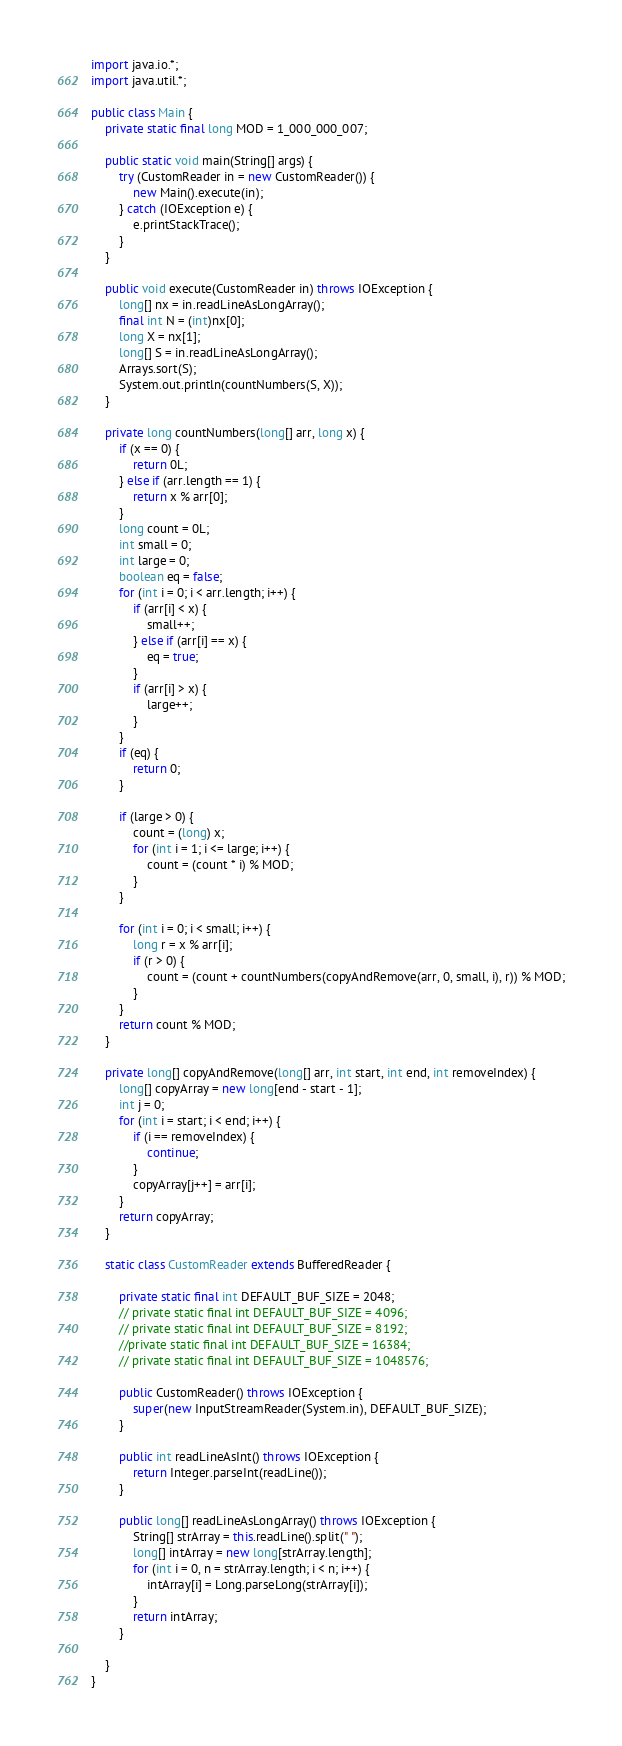<code> <loc_0><loc_0><loc_500><loc_500><_Java_>import java.io.*;
import java.util.*;

public class Main {
    private static final long MOD = 1_000_000_007;

    public static void main(String[] args) {
        try (CustomReader in = new CustomReader()) {
            new Main().execute(in);
        } catch (IOException e) {
            e.printStackTrace();
        }
    }

    public void execute(CustomReader in) throws IOException {
        long[] nx = in.readLineAsLongArray();
        final int N = (int)nx[0];
        long X = nx[1];
        long[] S = in.readLineAsLongArray();
        Arrays.sort(S);
        System.out.println(countNumbers(S, X));
    }

    private long countNumbers(long[] arr, long x) {
        if (x == 0) {
            return 0L;
        } else if (arr.length == 1) {
            return x % arr[0];
        }
        long count = 0L;
        int small = 0;
        int large = 0;
        boolean eq = false;
        for (int i = 0; i < arr.length; i++) {
            if (arr[i] < x) {
                small++;
            } else if (arr[i] == x) {
                eq = true;
            }
            if (arr[i] > x) {
                large++;
            }
        }
        if (eq) {
            return 0;
        }

        if (large > 0) {
            count = (long) x;
            for (int i = 1; i <= large; i++) {
                count = (count * i) % MOD;
            }
        }

        for (int i = 0; i < small; i++) {
            long r = x % arr[i];
            if (r > 0) {
                count = (count + countNumbers(copyAndRemove(arr, 0, small, i), r)) % MOD;
            }
        }
        return count % MOD;
    }

    private long[] copyAndRemove(long[] arr, int start, int end, int removeIndex) {
        long[] copyArray = new long[end - start - 1];
        int j = 0;
        for (int i = start; i < end; i++) {
            if (i == removeIndex) {
                continue;
            }
            copyArray[j++] = arr[i];
        }
        return copyArray;
    }

    static class CustomReader extends BufferedReader {

        private static final int DEFAULT_BUF_SIZE = 2048;
        // private static final int DEFAULT_BUF_SIZE = 4096;
        // private static final int DEFAULT_BUF_SIZE = 8192;
        //private static final int DEFAULT_BUF_SIZE = 16384;
        // private static final int DEFAULT_BUF_SIZE = 1048576;

        public CustomReader() throws IOException {
            super(new InputStreamReader(System.in), DEFAULT_BUF_SIZE);
        }

        public int readLineAsInt() throws IOException {
            return Integer.parseInt(readLine());
        }

        public long[] readLineAsLongArray() throws IOException {
            String[] strArray = this.readLine().split(" ");
            long[] intArray = new long[strArray.length];
            for (int i = 0, n = strArray.length; i < n; i++) {
                intArray[i] = Long.parseLong(strArray[i]);
            }
            return intArray;
        }

    }
}</code> 